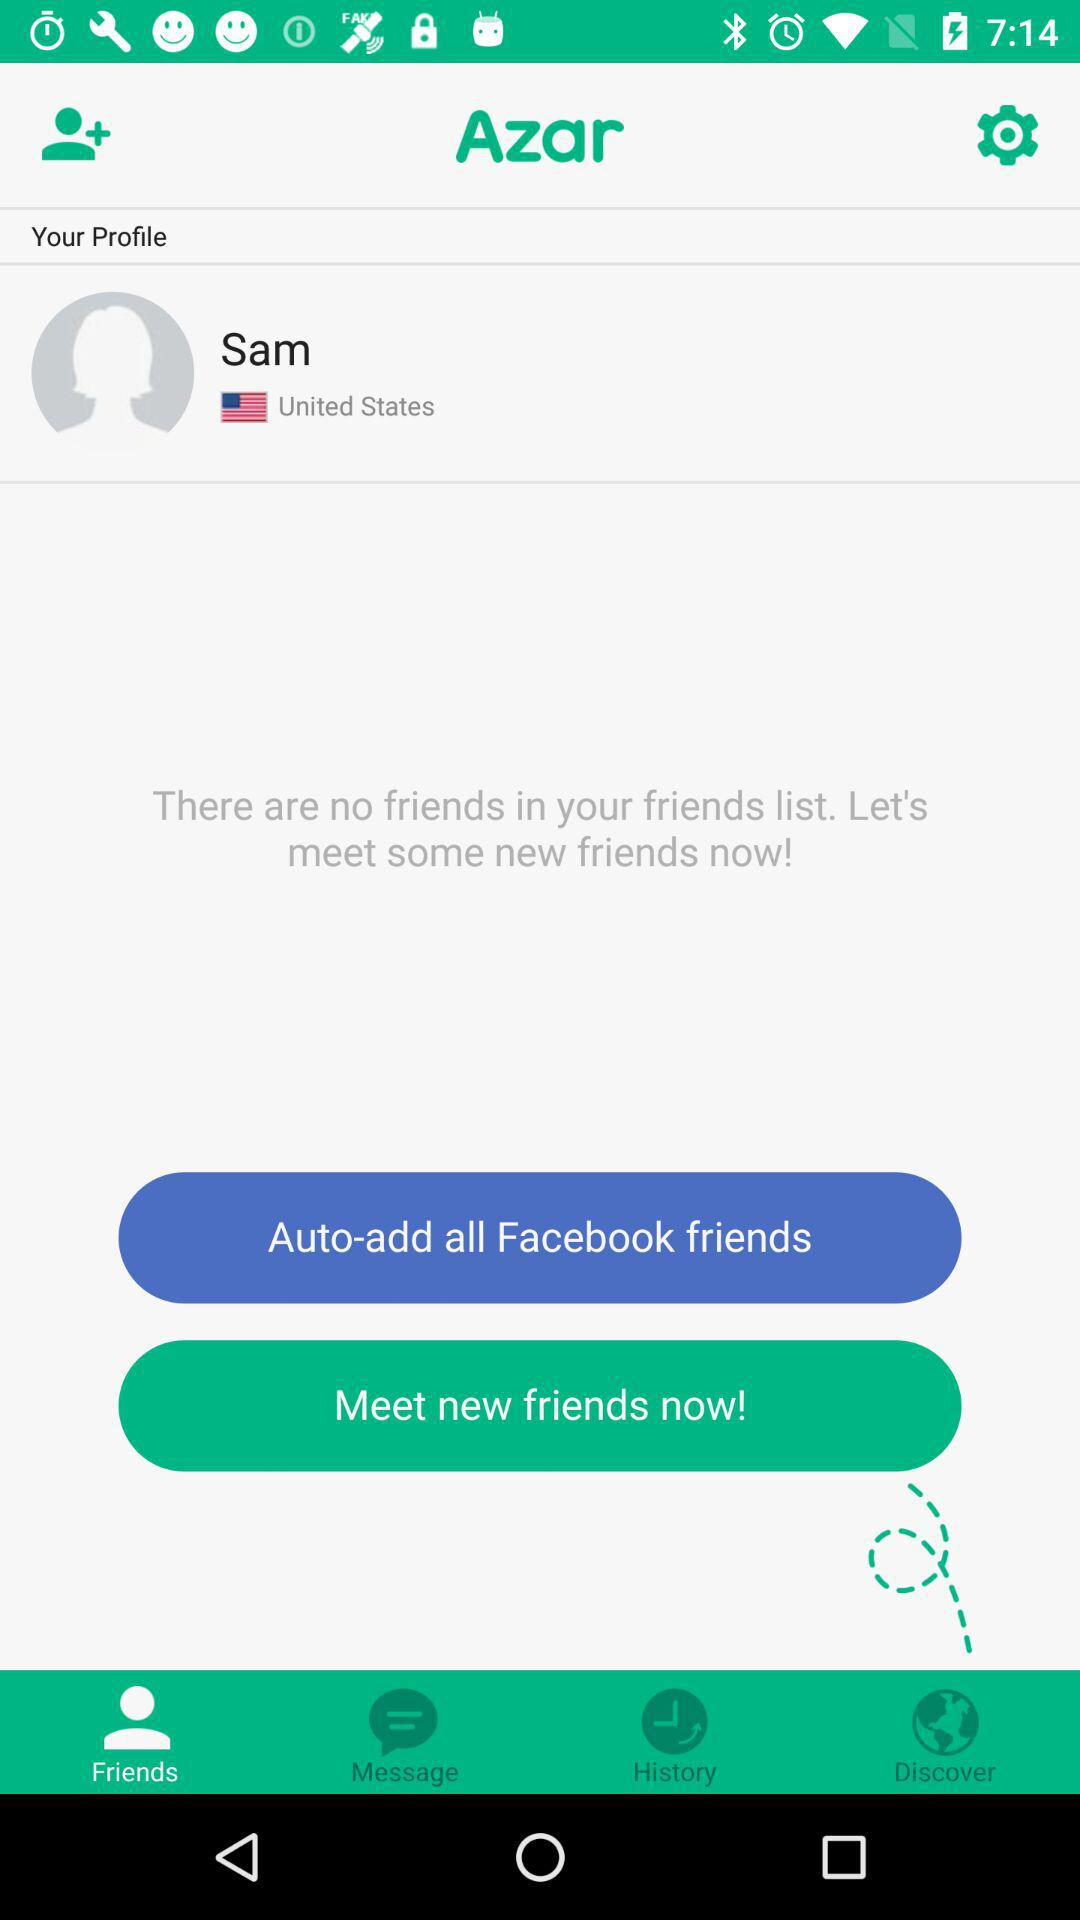What is the name of the user? The name of the user is Sam. 